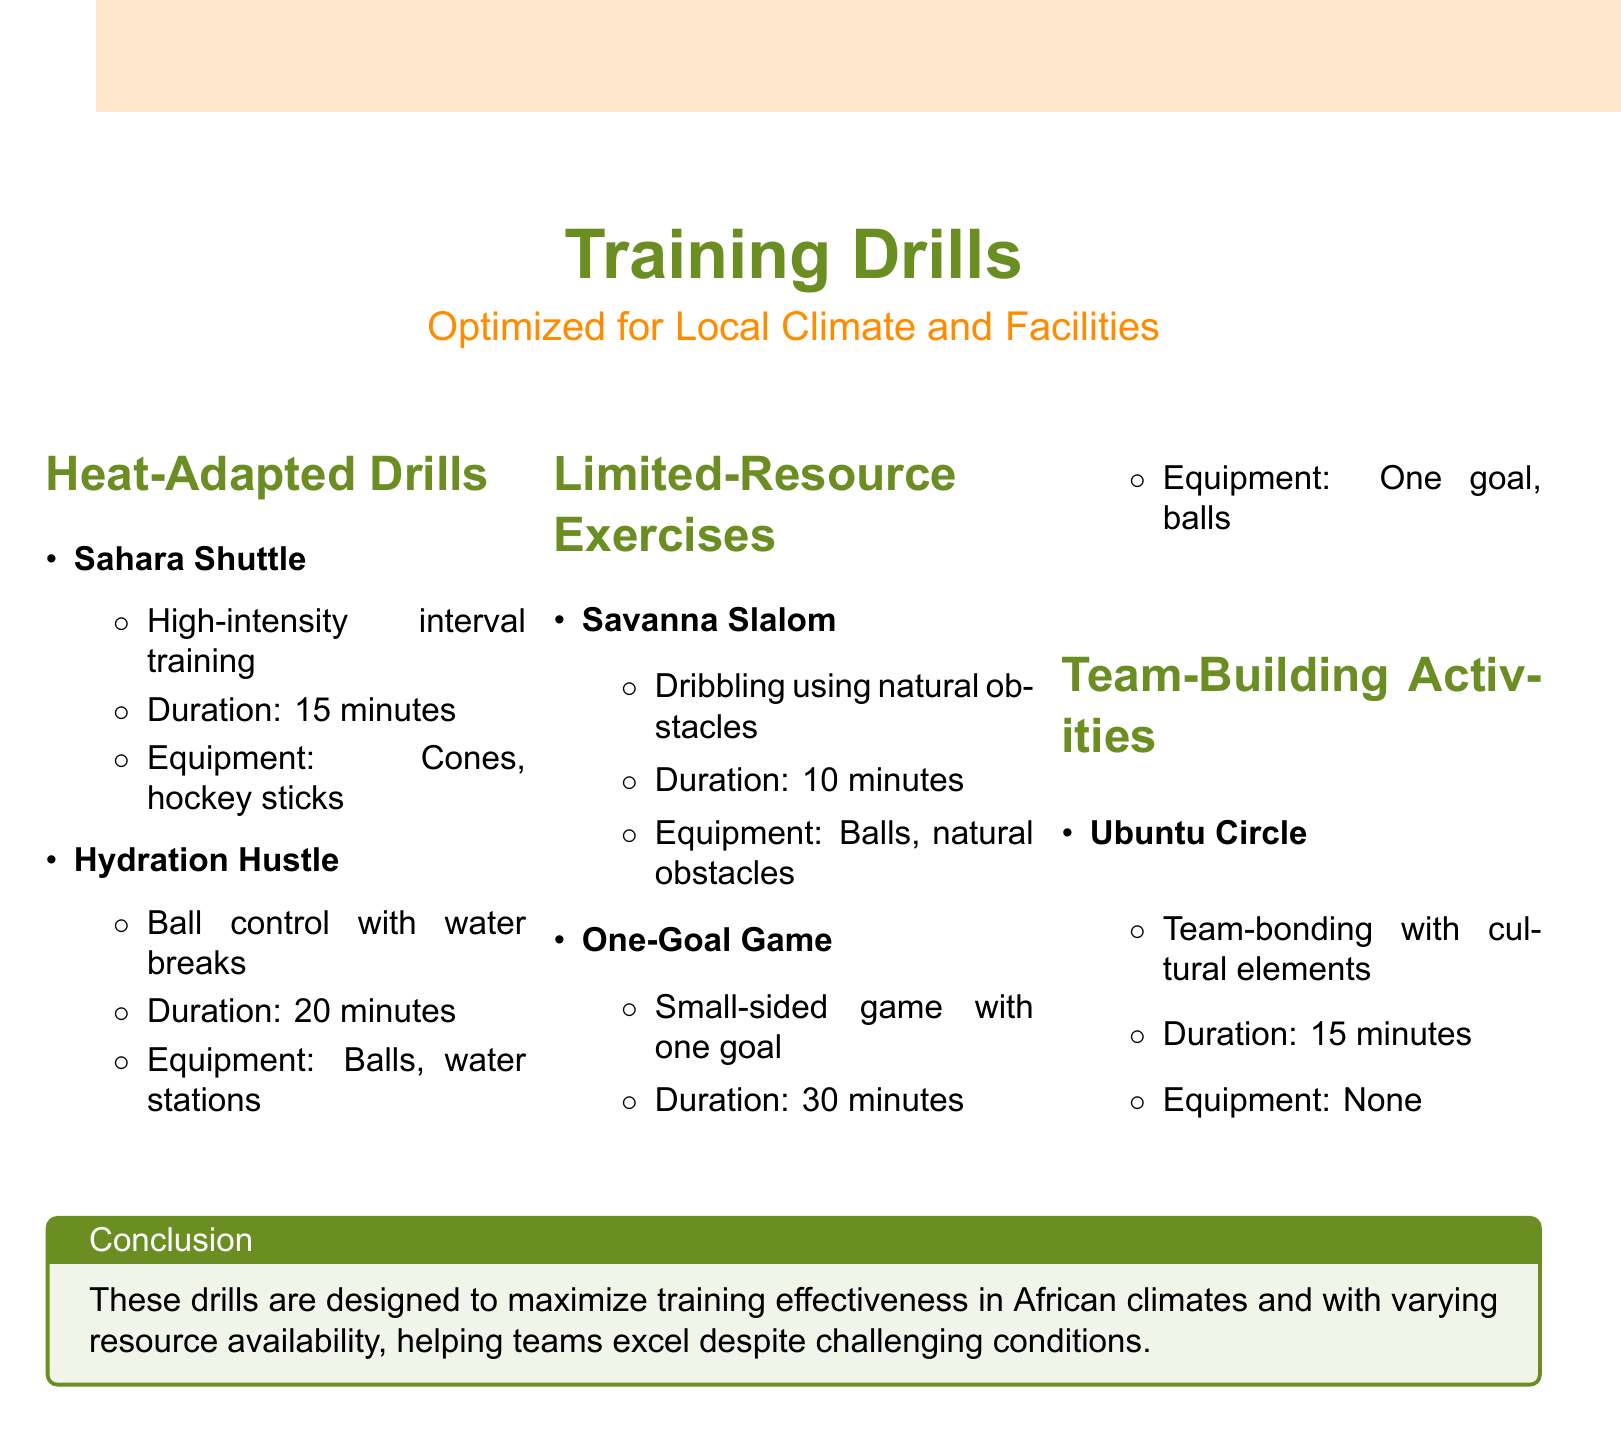What is the title of the catalog? The title can be found at the top of the document, which highlights the focus on training drills and exercises.
Answer: An illustrated catalog of training drills and exercises tailored for African climate conditions and facilities What is the duration of the Sahara Shuttle drill? The duration is specified in the document under the Sahara Shuttle drill description.
Answer: 15 minutes How many sections are there in the drills part of the document? The number of sections can be counted in the list provided in the training drills area of the document.
Answer: Three What type of game is the One-Goal Game? The type of game is mentioned in the description of the One-Goal Game under the Limited-Resource Exercises section.
Answer: Small-sided game What is the main goal of the Ubuntu Circle activity? The main goal is highlighted in the description of the Ubuntu Circle in the Team-Building Activities section.
Answer: Team-bonding What equipment is needed for the Hydration Hustle? The document specifies the required equipment for the Hydration Hustle drill in its description.
Answer: Balls, water stations How long is the duration of the One-Goal Game? The duration is provided in the description of the One-Goal Game under the Limited-Resource Exercises section.
Answer: 30 minutes What color is used for the training drills section header? The color can be found in the styles used for the section headers and titles in the document.
Answer: Savannagreen 